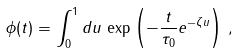Convert formula to latex. <formula><loc_0><loc_0><loc_500><loc_500>\phi ( t ) = \int _ { 0 } ^ { 1 } d u \, \exp \left ( - \frac { t } { \tau _ { 0 } } e ^ { - \zeta u } \right ) \, ,</formula> 